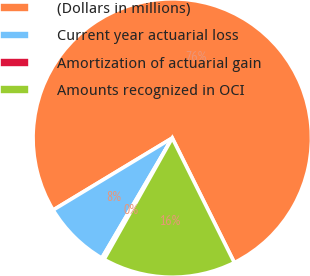Convert chart. <chart><loc_0><loc_0><loc_500><loc_500><pie_chart><fcel>(Dollars in millions)<fcel>Current year actuarial loss<fcel>Amortization of actuarial gain<fcel>Amounts recognized in OCI<nl><fcel>76.29%<fcel>7.9%<fcel>0.3%<fcel>15.5%<nl></chart> 